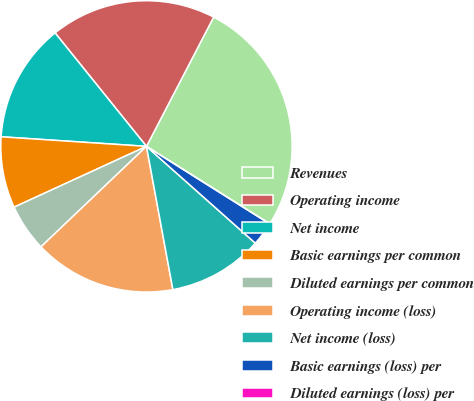Convert chart. <chart><loc_0><loc_0><loc_500><loc_500><pie_chart><fcel>Revenues<fcel>Operating income<fcel>Net income<fcel>Basic earnings per common<fcel>Diluted earnings per common<fcel>Operating income (loss)<fcel>Net income (loss)<fcel>Basic earnings (loss) per<fcel>Diluted earnings (loss) per<nl><fcel>26.31%<fcel>18.42%<fcel>13.16%<fcel>7.9%<fcel>5.26%<fcel>15.79%<fcel>10.53%<fcel>2.63%<fcel>0.0%<nl></chart> 